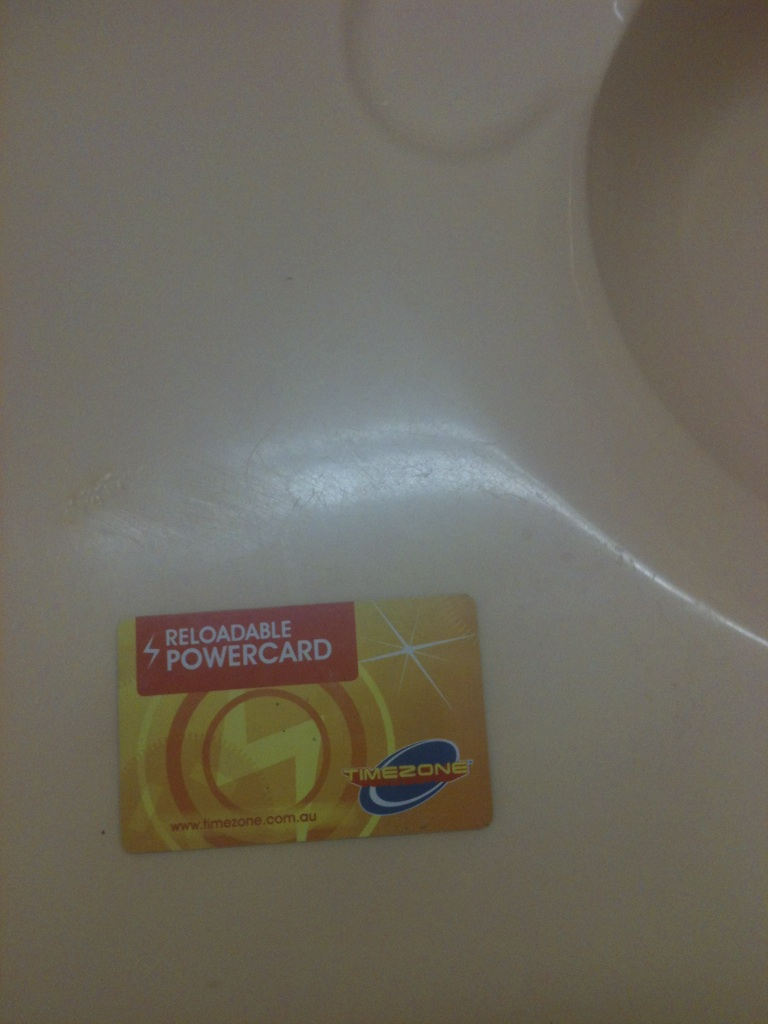What can you do with this type of card? A Reloadable Powercard from Timezone can be used to play games at Timezone centers. You load the card with credits and swipe it at machines to play games. Credits can also be used to earn points and redeem prizes. 